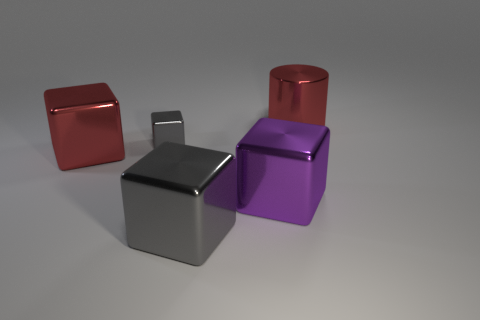Do the tiny gray metallic thing and the shiny thing right of the big purple metal object have the same shape?
Offer a terse response. No. Is the number of tiny gray objects greater than the number of large green cubes?
Ensure brevity in your answer.  Yes. Are there any other things that are the same size as the metallic cylinder?
Your response must be concise. Yes. There is a red object that is right of the large red block; is its shape the same as the small metallic thing?
Offer a terse response. No. Is the number of big shiny things that are behind the large red metal block greater than the number of purple shiny things?
Give a very brief answer. No. The large cube left of the gray thing behind the big red metal block is what color?
Offer a very short reply. Red. How many big red rubber objects are there?
Keep it short and to the point. 0. What number of large metal things are to the right of the big gray object and in front of the red shiny block?
Offer a very short reply. 1. Are there any other things that are the same shape as the big purple metal object?
Offer a very short reply. Yes. There is a small cube; does it have the same color as the block on the right side of the big gray object?
Ensure brevity in your answer.  No. 